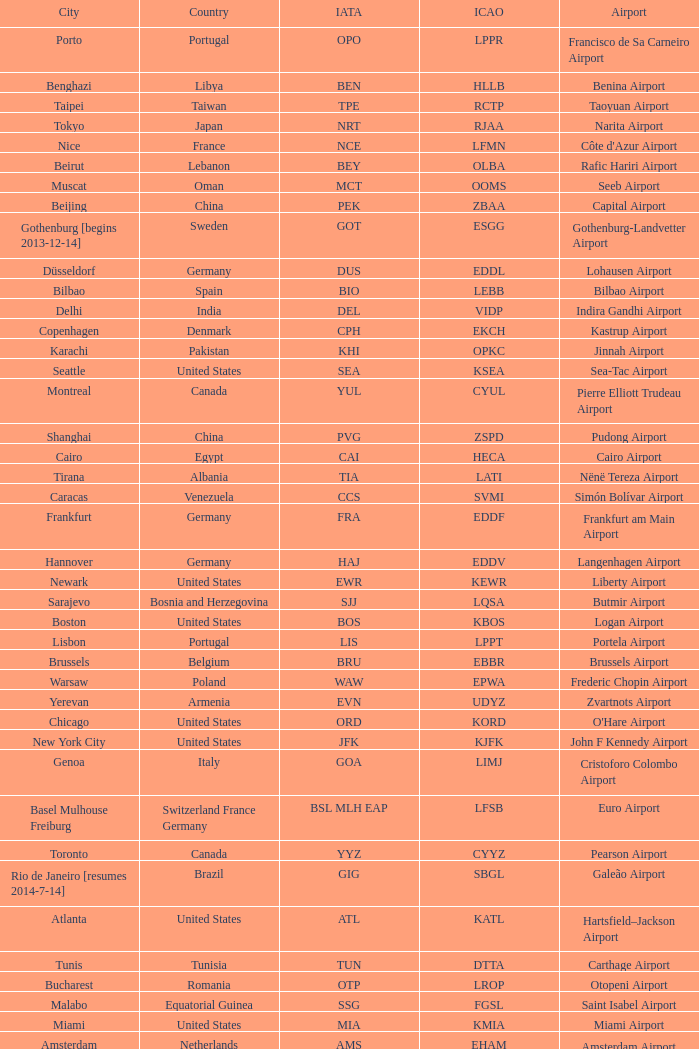What city is fuhlsbüttel airport in? Hamburg. 